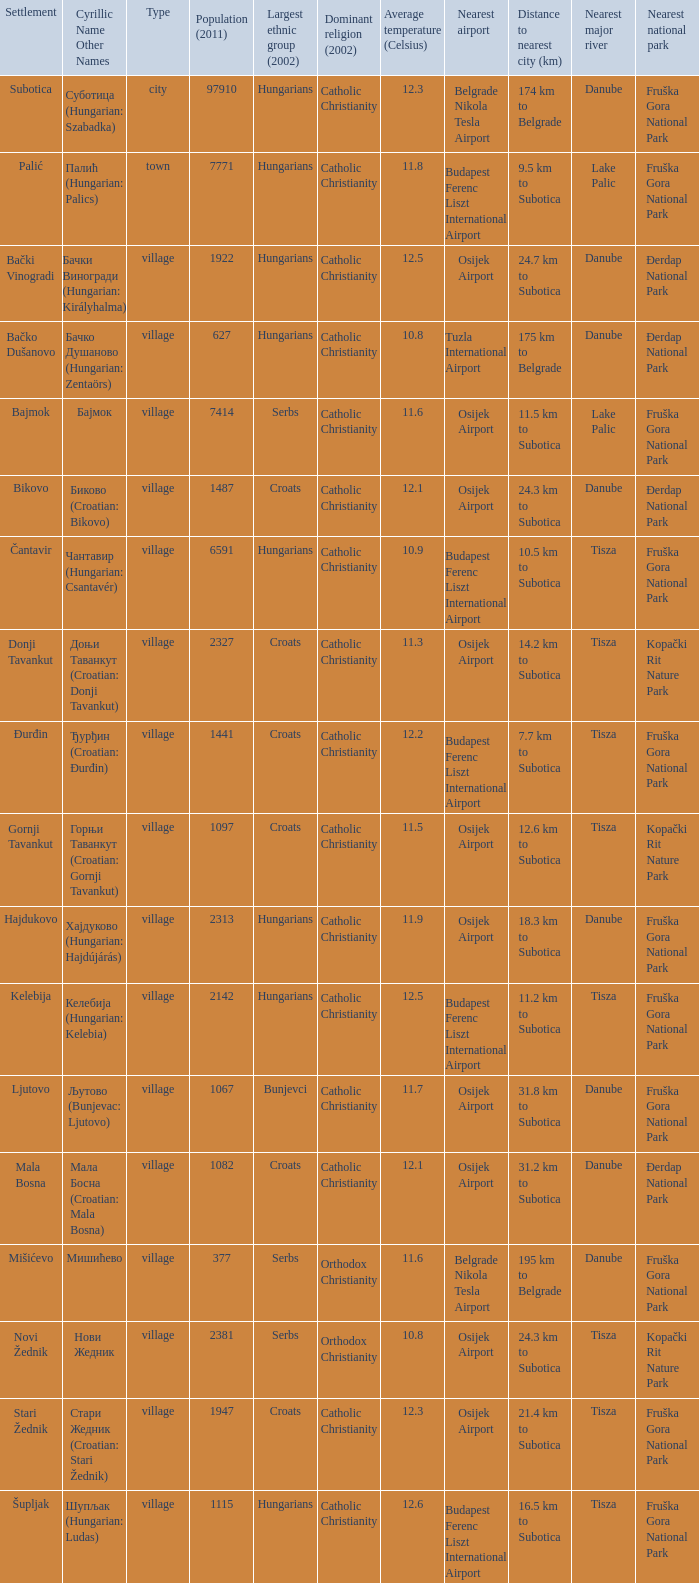What is the population in стари жедник (croatian: stari žednik)? 1947.0. 